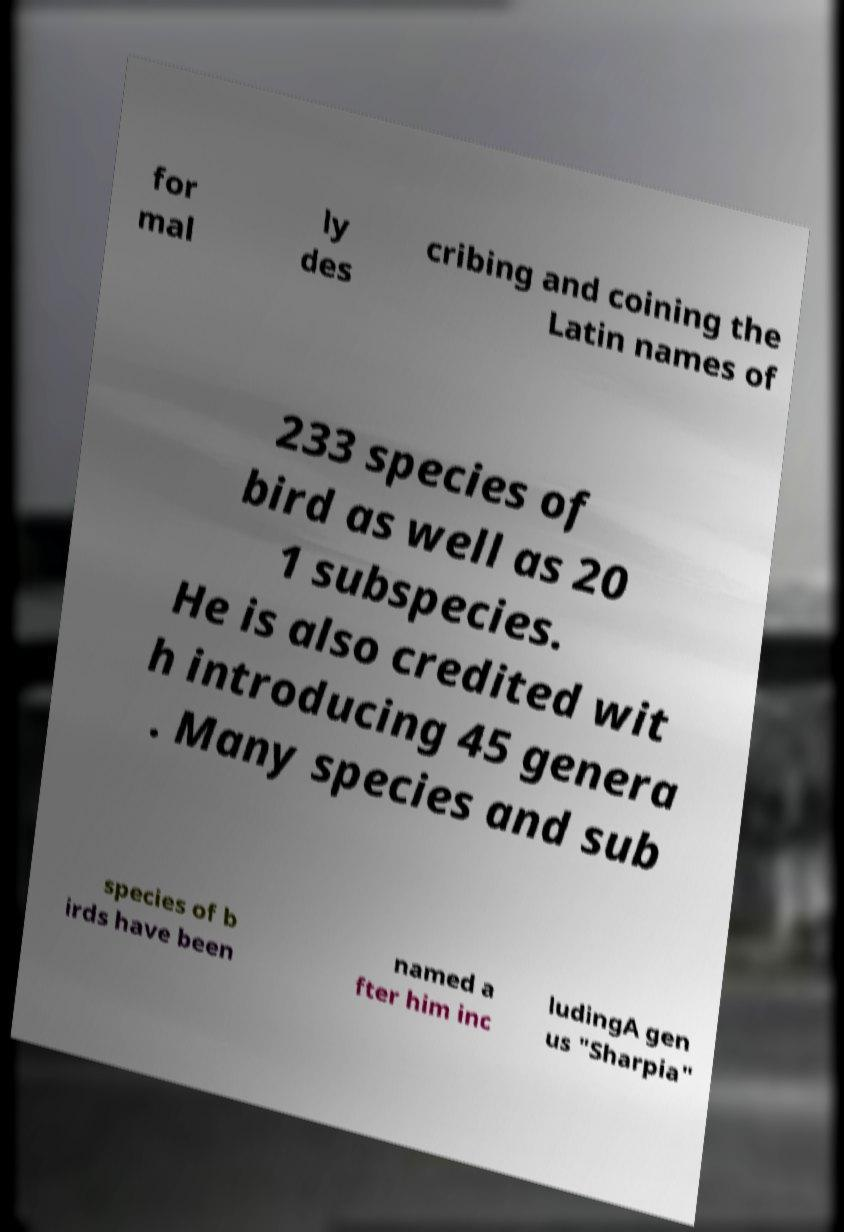Can you read and provide the text displayed in the image?This photo seems to have some interesting text. Can you extract and type it out for me? for mal ly des cribing and coining the Latin names of 233 species of bird as well as 20 1 subspecies. He is also credited wit h introducing 45 genera . Many species and sub species of b irds have been named a fter him inc ludingA gen us "Sharpia" 